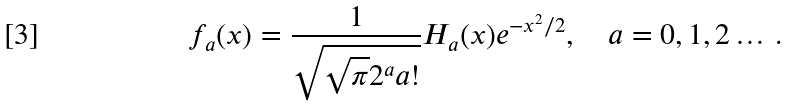Convert formula to latex. <formula><loc_0><loc_0><loc_500><loc_500>f _ { a } ( x ) = \frac { 1 } { \sqrt { \sqrt { \pi } 2 ^ { a } a ! } } H _ { a } ( x ) e ^ { - x ^ { 2 } / 2 } , \quad a = 0 , 1 , 2 \dots \, .</formula> 